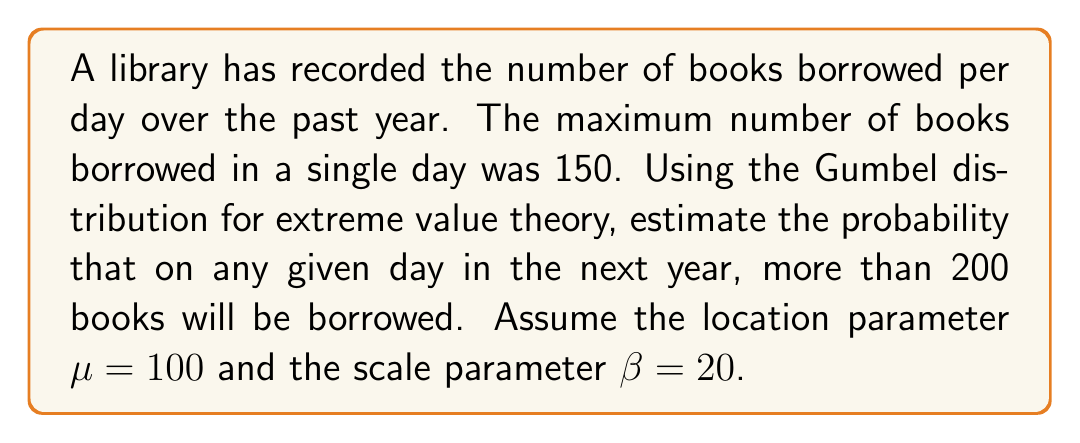What is the answer to this math problem? To solve this problem, we'll use the Gumbel distribution, which is commonly used in extreme value theory. The cumulative distribution function (CDF) of the Gumbel distribution is:

$$F(x) = e^{-e^{-(x-\mu)/\beta}}$$

Where:
$\mu$ is the location parameter
$\beta$ is the scale parameter
$x$ is the value we're interested in

We want to find the probability that more than 200 books will be borrowed, which is the complement of the probability that 200 or fewer books will be borrowed:

$$P(X > 200) = 1 - P(X \leq 200) = 1 - F(200)$$

Step 1: Calculate F(200) using the given parameters:
$$F(200) = e^{-e^{-(200-100)/20}}$$

Step 2: Simplify the exponent:
$$F(200) = e^{-e^{-5}}$$

Step 3: Calculate the value (you can use a calculator):
$$F(200) \approx 0.9933$$

Step 4: Calculate the probability of exceeding 200 books:
$$P(X > 200) = 1 - F(200) = 1 - 0.9933 \approx 0.0067$$

Therefore, the probability of more than 200 books being borrowed on any given day in the next year is approximately 0.0067 or 0.67%.
Answer: 0.0067 